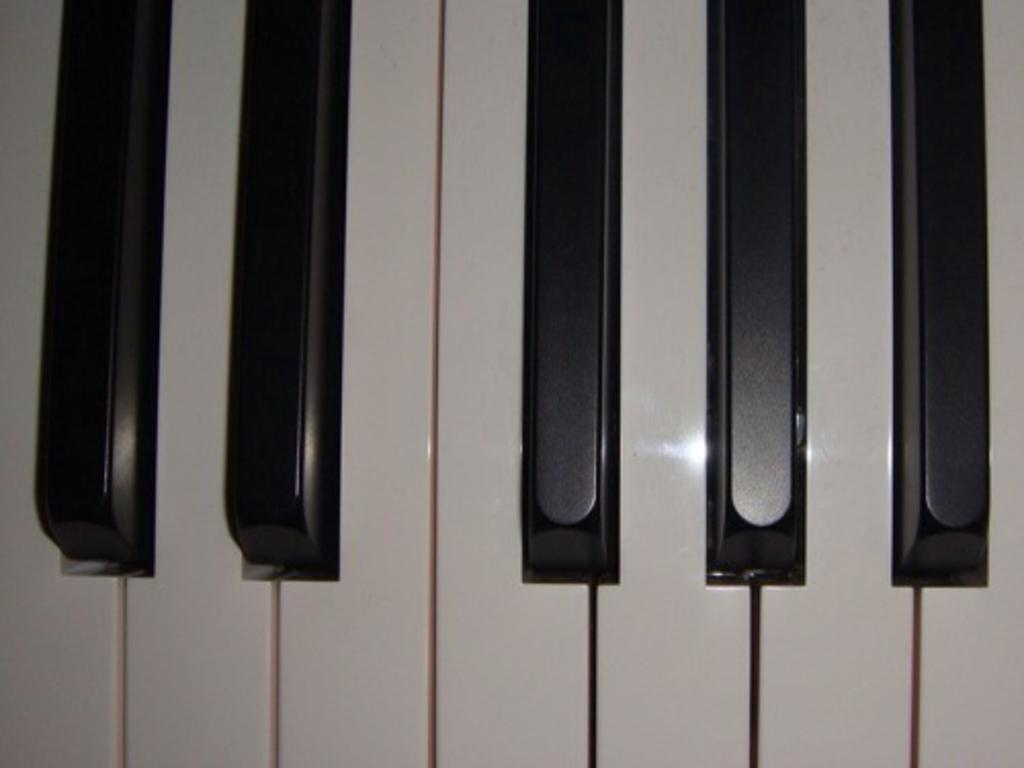What musical instrument is featured in the image? The image features keys of a piano. How many black keys are visible on the piano? There are five black keys on the piano. How many white keys are visible on the piano? There are seven white keys on the piano. What type of market is visible in the image? There is no market present in the image; it features piano keys. Can you describe the taste of the piano keys in the image? Piano keys are not edible and do not have a taste. 